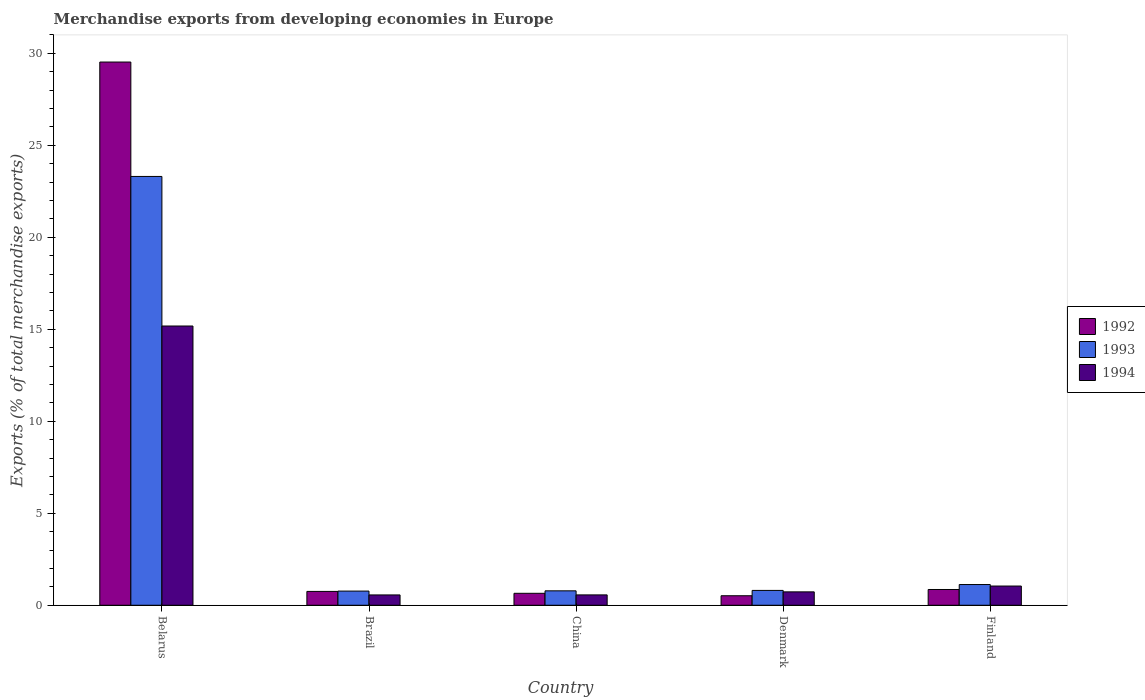How many different coloured bars are there?
Your answer should be compact. 3. Are the number of bars per tick equal to the number of legend labels?
Make the answer very short. Yes. Are the number of bars on each tick of the X-axis equal?
Make the answer very short. Yes. How many bars are there on the 5th tick from the left?
Offer a very short reply. 3. How many bars are there on the 2nd tick from the right?
Ensure brevity in your answer.  3. In how many cases, is the number of bars for a given country not equal to the number of legend labels?
Make the answer very short. 0. What is the percentage of total merchandise exports in 1993 in China?
Make the answer very short. 0.78. Across all countries, what is the maximum percentage of total merchandise exports in 1993?
Your answer should be compact. 23.31. Across all countries, what is the minimum percentage of total merchandise exports in 1992?
Provide a succinct answer. 0.52. In which country was the percentage of total merchandise exports in 1992 maximum?
Keep it short and to the point. Belarus. What is the total percentage of total merchandise exports in 1992 in the graph?
Provide a succinct answer. 32.3. What is the difference between the percentage of total merchandise exports in 1994 in Belarus and that in Denmark?
Provide a short and direct response. 14.45. What is the difference between the percentage of total merchandise exports in 1993 in China and the percentage of total merchandise exports in 1994 in Finland?
Make the answer very short. -0.26. What is the average percentage of total merchandise exports in 1994 per country?
Give a very brief answer. 3.62. What is the difference between the percentage of total merchandise exports of/in 1993 and percentage of total merchandise exports of/in 1994 in Belarus?
Make the answer very short. 8.13. In how many countries, is the percentage of total merchandise exports in 1994 greater than 26 %?
Your answer should be very brief. 0. What is the ratio of the percentage of total merchandise exports in 1993 in Brazil to that in Finland?
Your answer should be compact. 0.68. Is the percentage of total merchandise exports in 1994 in Belarus less than that in Finland?
Your response must be concise. No. Is the difference between the percentage of total merchandise exports in 1993 in Belarus and Brazil greater than the difference between the percentage of total merchandise exports in 1994 in Belarus and Brazil?
Ensure brevity in your answer.  Yes. What is the difference between the highest and the second highest percentage of total merchandise exports in 1994?
Keep it short and to the point. -0.32. What is the difference between the highest and the lowest percentage of total merchandise exports in 1992?
Provide a short and direct response. 29.01. How many bars are there?
Ensure brevity in your answer.  15. What is the difference between two consecutive major ticks on the Y-axis?
Give a very brief answer. 5. Are the values on the major ticks of Y-axis written in scientific E-notation?
Your answer should be compact. No. Does the graph contain grids?
Offer a terse response. No. Where does the legend appear in the graph?
Your answer should be compact. Center right. How many legend labels are there?
Offer a very short reply. 3. How are the legend labels stacked?
Offer a very short reply. Vertical. What is the title of the graph?
Provide a succinct answer. Merchandise exports from developing economies in Europe. Does "2005" appear as one of the legend labels in the graph?
Provide a short and direct response. No. What is the label or title of the Y-axis?
Your answer should be very brief. Exports (% of total merchandise exports). What is the Exports (% of total merchandise exports) of 1992 in Belarus?
Offer a terse response. 29.53. What is the Exports (% of total merchandise exports) of 1993 in Belarus?
Provide a short and direct response. 23.31. What is the Exports (% of total merchandise exports) in 1994 in Belarus?
Provide a short and direct response. 15.18. What is the Exports (% of total merchandise exports) in 1992 in Brazil?
Keep it short and to the point. 0.75. What is the Exports (% of total merchandise exports) of 1993 in Brazil?
Your answer should be compact. 0.77. What is the Exports (% of total merchandise exports) of 1994 in Brazil?
Your answer should be very brief. 0.56. What is the Exports (% of total merchandise exports) in 1992 in China?
Provide a short and direct response. 0.65. What is the Exports (% of total merchandise exports) of 1993 in China?
Make the answer very short. 0.78. What is the Exports (% of total merchandise exports) of 1994 in China?
Offer a very short reply. 0.56. What is the Exports (% of total merchandise exports) in 1992 in Denmark?
Your response must be concise. 0.52. What is the Exports (% of total merchandise exports) in 1993 in Denmark?
Give a very brief answer. 0.81. What is the Exports (% of total merchandise exports) in 1994 in Denmark?
Make the answer very short. 0.73. What is the Exports (% of total merchandise exports) in 1992 in Finland?
Make the answer very short. 0.86. What is the Exports (% of total merchandise exports) of 1993 in Finland?
Give a very brief answer. 1.13. What is the Exports (% of total merchandise exports) of 1994 in Finland?
Your answer should be very brief. 1.05. Across all countries, what is the maximum Exports (% of total merchandise exports) of 1992?
Make the answer very short. 29.53. Across all countries, what is the maximum Exports (% of total merchandise exports) of 1993?
Offer a terse response. 23.31. Across all countries, what is the maximum Exports (% of total merchandise exports) of 1994?
Ensure brevity in your answer.  15.18. Across all countries, what is the minimum Exports (% of total merchandise exports) of 1992?
Keep it short and to the point. 0.52. Across all countries, what is the minimum Exports (% of total merchandise exports) of 1993?
Offer a very short reply. 0.77. Across all countries, what is the minimum Exports (% of total merchandise exports) of 1994?
Your response must be concise. 0.56. What is the total Exports (% of total merchandise exports) of 1992 in the graph?
Offer a terse response. 32.3. What is the total Exports (% of total merchandise exports) of 1993 in the graph?
Keep it short and to the point. 26.8. What is the total Exports (% of total merchandise exports) in 1994 in the graph?
Your answer should be compact. 18.08. What is the difference between the Exports (% of total merchandise exports) in 1992 in Belarus and that in Brazil?
Offer a very short reply. 28.77. What is the difference between the Exports (% of total merchandise exports) of 1993 in Belarus and that in Brazil?
Provide a succinct answer. 22.54. What is the difference between the Exports (% of total merchandise exports) in 1994 in Belarus and that in Brazil?
Provide a succinct answer. 14.62. What is the difference between the Exports (% of total merchandise exports) of 1992 in Belarus and that in China?
Your answer should be compact. 28.88. What is the difference between the Exports (% of total merchandise exports) of 1993 in Belarus and that in China?
Offer a terse response. 22.52. What is the difference between the Exports (% of total merchandise exports) of 1994 in Belarus and that in China?
Your response must be concise. 14.62. What is the difference between the Exports (% of total merchandise exports) of 1992 in Belarus and that in Denmark?
Your answer should be compact. 29.01. What is the difference between the Exports (% of total merchandise exports) of 1993 in Belarus and that in Denmark?
Your answer should be very brief. 22.5. What is the difference between the Exports (% of total merchandise exports) of 1994 in Belarus and that in Denmark?
Your answer should be very brief. 14.45. What is the difference between the Exports (% of total merchandise exports) of 1992 in Belarus and that in Finland?
Offer a terse response. 28.67. What is the difference between the Exports (% of total merchandise exports) in 1993 in Belarus and that in Finland?
Make the answer very short. 22.18. What is the difference between the Exports (% of total merchandise exports) in 1994 in Belarus and that in Finland?
Offer a terse response. 14.13. What is the difference between the Exports (% of total merchandise exports) of 1992 in Brazil and that in China?
Keep it short and to the point. 0.1. What is the difference between the Exports (% of total merchandise exports) of 1993 in Brazil and that in China?
Offer a terse response. -0.01. What is the difference between the Exports (% of total merchandise exports) in 1994 in Brazil and that in China?
Offer a terse response. -0. What is the difference between the Exports (% of total merchandise exports) in 1992 in Brazil and that in Denmark?
Offer a very short reply. 0.24. What is the difference between the Exports (% of total merchandise exports) in 1993 in Brazil and that in Denmark?
Provide a succinct answer. -0.04. What is the difference between the Exports (% of total merchandise exports) of 1994 in Brazil and that in Denmark?
Provide a short and direct response. -0.17. What is the difference between the Exports (% of total merchandise exports) of 1992 in Brazil and that in Finland?
Offer a terse response. -0.1. What is the difference between the Exports (% of total merchandise exports) of 1993 in Brazil and that in Finland?
Make the answer very short. -0.36. What is the difference between the Exports (% of total merchandise exports) in 1994 in Brazil and that in Finland?
Offer a very short reply. -0.48. What is the difference between the Exports (% of total merchandise exports) in 1992 in China and that in Denmark?
Your answer should be compact. 0.13. What is the difference between the Exports (% of total merchandise exports) in 1993 in China and that in Denmark?
Ensure brevity in your answer.  -0.02. What is the difference between the Exports (% of total merchandise exports) of 1994 in China and that in Denmark?
Your response must be concise. -0.17. What is the difference between the Exports (% of total merchandise exports) in 1992 in China and that in Finland?
Ensure brevity in your answer.  -0.21. What is the difference between the Exports (% of total merchandise exports) in 1993 in China and that in Finland?
Your answer should be very brief. -0.34. What is the difference between the Exports (% of total merchandise exports) of 1994 in China and that in Finland?
Make the answer very short. -0.48. What is the difference between the Exports (% of total merchandise exports) of 1992 in Denmark and that in Finland?
Keep it short and to the point. -0.34. What is the difference between the Exports (% of total merchandise exports) of 1993 in Denmark and that in Finland?
Provide a short and direct response. -0.32. What is the difference between the Exports (% of total merchandise exports) of 1994 in Denmark and that in Finland?
Your answer should be very brief. -0.32. What is the difference between the Exports (% of total merchandise exports) of 1992 in Belarus and the Exports (% of total merchandise exports) of 1993 in Brazil?
Your answer should be compact. 28.76. What is the difference between the Exports (% of total merchandise exports) in 1992 in Belarus and the Exports (% of total merchandise exports) in 1994 in Brazil?
Provide a succinct answer. 28.97. What is the difference between the Exports (% of total merchandise exports) of 1993 in Belarus and the Exports (% of total merchandise exports) of 1994 in Brazil?
Your answer should be compact. 22.75. What is the difference between the Exports (% of total merchandise exports) in 1992 in Belarus and the Exports (% of total merchandise exports) in 1993 in China?
Provide a short and direct response. 28.74. What is the difference between the Exports (% of total merchandise exports) in 1992 in Belarus and the Exports (% of total merchandise exports) in 1994 in China?
Provide a succinct answer. 28.96. What is the difference between the Exports (% of total merchandise exports) of 1993 in Belarus and the Exports (% of total merchandise exports) of 1994 in China?
Offer a terse response. 22.75. What is the difference between the Exports (% of total merchandise exports) of 1992 in Belarus and the Exports (% of total merchandise exports) of 1993 in Denmark?
Make the answer very short. 28.72. What is the difference between the Exports (% of total merchandise exports) of 1992 in Belarus and the Exports (% of total merchandise exports) of 1994 in Denmark?
Your answer should be very brief. 28.8. What is the difference between the Exports (% of total merchandise exports) in 1993 in Belarus and the Exports (% of total merchandise exports) in 1994 in Denmark?
Provide a succinct answer. 22.58. What is the difference between the Exports (% of total merchandise exports) of 1992 in Belarus and the Exports (% of total merchandise exports) of 1993 in Finland?
Give a very brief answer. 28.4. What is the difference between the Exports (% of total merchandise exports) of 1992 in Belarus and the Exports (% of total merchandise exports) of 1994 in Finland?
Offer a very short reply. 28.48. What is the difference between the Exports (% of total merchandise exports) of 1993 in Belarus and the Exports (% of total merchandise exports) of 1994 in Finland?
Offer a very short reply. 22.26. What is the difference between the Exports (% of total merchandise exports) of 1992 in Brazil and the Exports (% of total merchandise exports) of 1993 in China?
Provide a short and direct response. -0.03. What is the difference between the Exports (% of total merchandise exports) of 1992 in Brazil and the Exports (% of total merchandise exports) of 1994 in China?
Provide a succinct answer. 0.19. What is the difference between the Exports (% of total merchandise exports) of 1993 in Brazil and the Exports (% of total merchandise exports) of 1994 in China?
Keep it short and to the point. 0.21. What is the difference between the Exports (% of total merchandise exports) of 1992 in Brazil and the Exports (% of total merchandise exports) of 1993 in Denmark?
Give a very brief answer. -0.05. What is the difference between the Exports (% of total merchandise exports) in 1992 in Brazil and the Exports (% of total merchandise exports) in 1994 in Denmark?
Keep it short and to the point. 0.02. What is the difference between the Exports (% of total merchandise exports) of 1993 in Brazil and the Exports (% of total merchandise exports) of 1994 in Denmark?
Offer a very short reply. 0.04. What is the difference between the Exports (% of total merchandise exports) of 1992 in Brazil and the Exports (% of total merchandise exports) of 1993 in Finland?
Your response must be concise. -0.37. What is the difference between the Exports (% of total merchandise exports) in 1992 in Brazil and the Exports (% of total merchandise exports) in 1994 in Finland?
Keep it short and to the point. -0.29. What is the difference between the Exports (% of total merchandise exports) in 1993 in Brazil and the Exports (% of total merchandise exports) in 1994 in Finland?
Provide a succinct answer. -0.27. What is the difference between the Exports (% of total merchandise exports) in 1992 in China and the Exports (% of total merchandise exports) in 1993 in Denmark?
Keep it short and to the point. -0.16. What is the difference between the Exports (% of total merchandise exports) in 1992 in China and the Exports (% of total merchandise exports) in 1994 in Denmark?
Ensure brevity in your answer.  -0.08. What is the difference between the Exports (% of total merchandise exports) of 1993 in China and the Exports (% of total merchandise exports) of 1994 in Denmark?
Make the answer very short. 0.06. What is the difference between the Exports (% of total merchandise exports) of 1992 in China and the Exports (% of total merchandise exports) of 1993 in Finland?
Make the answer very short. -0.48. What is the difference between the Exports (% of total merchandise exports) in 1992 in China and the Exports (% of total merchandise exports) in 1994 in Finland?
Provide a short and direct response. -0.4. What is the difference between the Exports (% of total merchandise exports) of 1993 in China and the Exports (% of total merchandise exports) of 1994 in Finland?
Your answer should be compact. -0.26. What is the difference between the Exports (% of total merchandise exports) in 1992 in Denmark and the Exports (% of total merchandise exports) in 1993 in Finland?
Provide a succinct answer. -0.61. What is the difference between the Exports (% of total merchandise exports) of 1992 in Denmark and the Exports (% of total merchandise exports) of 1994 in Finland?
Provide a succinct answer. -0.53. What is the difference between the Exports (% of total merchandise exports) of 1993 in Denmark and the Exports (% of total merchandise exports) of 1994 in Finland?
Ensure brevity in your answer.  -0.24. What is the average Exports (% of total merchandise exports) of 1992 per country?
Keep it short and to the point. 6.46. What is the average Exports (% of total merchandise exports) in 1993 per country?
Your response must be concise. 5.36. What is the average Exports (% of total merchandise exports) of 1994 per country?
Provide a short and direct response. 3.62. What is the difference between the Exports (% of total merchandise exports) in 1992 and Exports (% of total merchandise exports) in 1993 in Belarus?
Provide a short and direct response. 6.22. What is the difference between the Exports (% of total merchandise exports) in 1992 and Exports (% of total merchandise exports) in 1994 in Belarus?
Make the answer very short. 14.35. What is the difference between the Exports (% of total merchandise exports) of 1993 and Exports (% of total merchandise exports) of 1994 in Belarus?
Ensure brevity in your answer.  8.13. What is the difference between the Exports (% of total merchandise exports) of 1992 and Exports (% of total merchandise exports) of 1993 in Brazil?
Offer a very short reply. -0.02. What is the difference between the Exports (% of total merchandise exports) in 1992 and Exports (% of total merchandise exports) in 1994 in Brazil?
Your answer should be very brief. 0.19. What is the difference between the Exports (% of total merchandise exports) in 1993 and Exports (% of total merchandise exports) in 1994 in Brazil?
Offer a very short reply. 0.21. What is the difference between the Exports (% of total merchandise exports) in 1992 and Exports (% of total merchandise exports) in 1993 in China?
Offer a very short reply. -0.13. What is the difference between the Exports (% of total merchandise exports) in 1992 and Exports (% of total merchandise exports) in 1994 in China?
Keep it short and to the point. 0.09. What is the difference between the Exports (% of total merchandise exports) in 1993 and Exports (% of total merchandise exports) in 1994 in China?
Your response must be concise. 0.22. What is the difference between the Exports (% of total merchandise exports) of 1992 and Exports (% of total merchandise exports) of 1993 in Denmark?
Offer a very short reply. -0.29. What is the difference between the Exports (% of total merchandise exports) of 1992 and Exports (% of total merchandise exports) of 1994 in Denmark?
Your response must be concise. -0.21. What is the difference between the Exports (% of total merchandise exports) of 1993 and Exports (% of total merchandise exports) of 1994 in Denmark?
Your answer should be compact. 0.08. What is the difference between the Exports (% of total merchandise exports) of 1992 and Exports (% of total merchandise exports) of 1993 in Finland?
Provide a short and direct response. -0.27. What is the difference between the Exports (% of total merchandise exports) in 1992 and Exports (% of total merchandise exports) in 1994 in Finland?
Your answer should be very brief. -0.19. What is the difference between the Exports (% of total merchandise exports) of 1993 and Exports (% of total merchandise exports) of 1994 in Finland?
Your response must be concise. 0.08. What is the ratio of the Exports (% of total merchandise exports) in 1992 in Belarus to that in Brazil?
Offer a very short reply. 39.22. What is the ratio of the Exports (% of total merchandise exports) of 1993 in Belarus to that in Brazil?
Offer a very short reply. 30.26. What is the ratio of the Exports (% of total merchandise exports) in 1994 in Belarus to that in Brazil?
Provide a succinct answer. 27.03. What is the ratio of the Exports (% of total merchandise exports) of 1992 in Belarus to that in China?
Your answer should be very brief. 45.45. What is the ratio of the Exports (% of total merchandise exports) in 1993 in Belarus to that in China?
Offer a terse response. 29.71. What is the ratio of the Exports (% of total merchandise exports) in 1994 in Belarus to that in China?
Your response must be concise. 26.95. What is the ratio of the Exports (% of total merchandise exports) in 1992 in Belarus to that in Denmark?
Your response must be concise. 57.06. What is the ratio of the Exports (% of total merchandise exports) in 1993 in Belarus to that in Denmark?
Make the answer very short. 28.88. What is the ratio of the Exports (% of total merchandise exports) of 1994 in Belarus to that in Denmark?
Your answer should be very brief. 20.84. What is the ratio of the Exports (% of total merchandise exports) of 1992 in Belarus to that in Finland?
Make the answer very short. 34.46. What is the ratio of the Exports (% of total merchandise exports) of 1993 in Belarus to that in Finland?
Your answer should be compact. 20.69. What is the ratio of the Exports (% of total merchandise exports) of 1994 in Belarus to that in Finland?
Provide a short and direct response. 14.52. What is the ratio of the Exports (% of total merchandise exports) of 1992 in Brazil to that in China?
Offer a very short reply. 1.16. What is the ratio of the Exports (% of total merchandise exports) in 1993 in Brazil to that in China?
Make the answer very short. 0.98. What is the ratio of the Exports (% of total merchandise exports) of 1992 in Brazil to that in Denmark?
Offer a very short reply. 1.46. What is the ratio of the Exports (% of total merchandise exports) of 1993 in Brazil to that in Denmark?
Offer a terse response. 0.95. What is the ratio of the Exports (% of total merchandise exports) of 1994 in Brazil to that in Denmark?
Offer a terse response. 0.77. What is the ratio of the Exports (% of total merchandise exports) of 1992 in Brazil to that in Finland?
Ensure brevity in your answer.  0.88. What is the ratio of the Exports (% of total merchandise exports) of 1993 in Brazil to that in Finland?
Keep it short and to the point. 0.68. What is the ratio of the Exports (% of total merchandise exports) of 1994 in Brazil to that in Finland?
Offer a terse response. 0.54. What is the ratio of the Exports (% of total merchandise exports) of 1992 in China to that in Denmark?
Your response must be concise. 1.26. What is the ratio of the Exports (% of total merchandise exports) in 1993 in China to that in Denmark?
Your response must be concise. 0.97. What is the ratio of the Exports (% of total merchandise exports) in 1994 in China to that in Denmark?
Make the answer very short. 0.77. What is the ratio of the Exports (% of total merchandise exports) in 1992 in China to that in Finland?
Your answer should be compact. 0.76. What is the ratio of the Exports (% of total merchandise exports) of 1993 in China to that in Finland?
Your response must be concise. 0.7. What is the ratio of the Exports (% of total merchandise exports) of 1994 in China to that in Finland?
Provide a succinct answer. 0.54. What is the ratio of the Exports (% of total merchandise exports) in 1992 in Denmark to that in Finland?
Offer a terse response. 0.6. What is the ratio of the Exports (% of total merchandise exports) of 1993 in Denmark to that in Finland?
Your response must be concise. 0.72. What is the ratio of the Exports (% of total merchandise exports) in 1994 in Denmark to that in Finland?
Your answer should be compact. 0.7. What is the difference between the highest and the second highest Exports (% of total merchandise exports) in 1992?
Provide a short and direct response. 28.67. What is the difference between the highest and the second highest Exports (% of total merchandise exports) in 1993?
Ensure brevity in your answer.  22.18. What is the difference between the highest and the second highest Exports (% of total merchandise exports) of 1994?
Make the answer very short. 14.13. What is the difference between the highest and the lowest Exports (% of total merchandise exports) in 1992?
Ensure brevity in your answer.  29.01. What is the difference between the highest and the lowest Exports (% of total merchandise exports) in 1993?
Ensure brevity in your answer.  22.54. What is the difference between the highest and the lowest Exports (% of total merchandise exports) in 1994?
Provide a short and direct response. 14.62. 